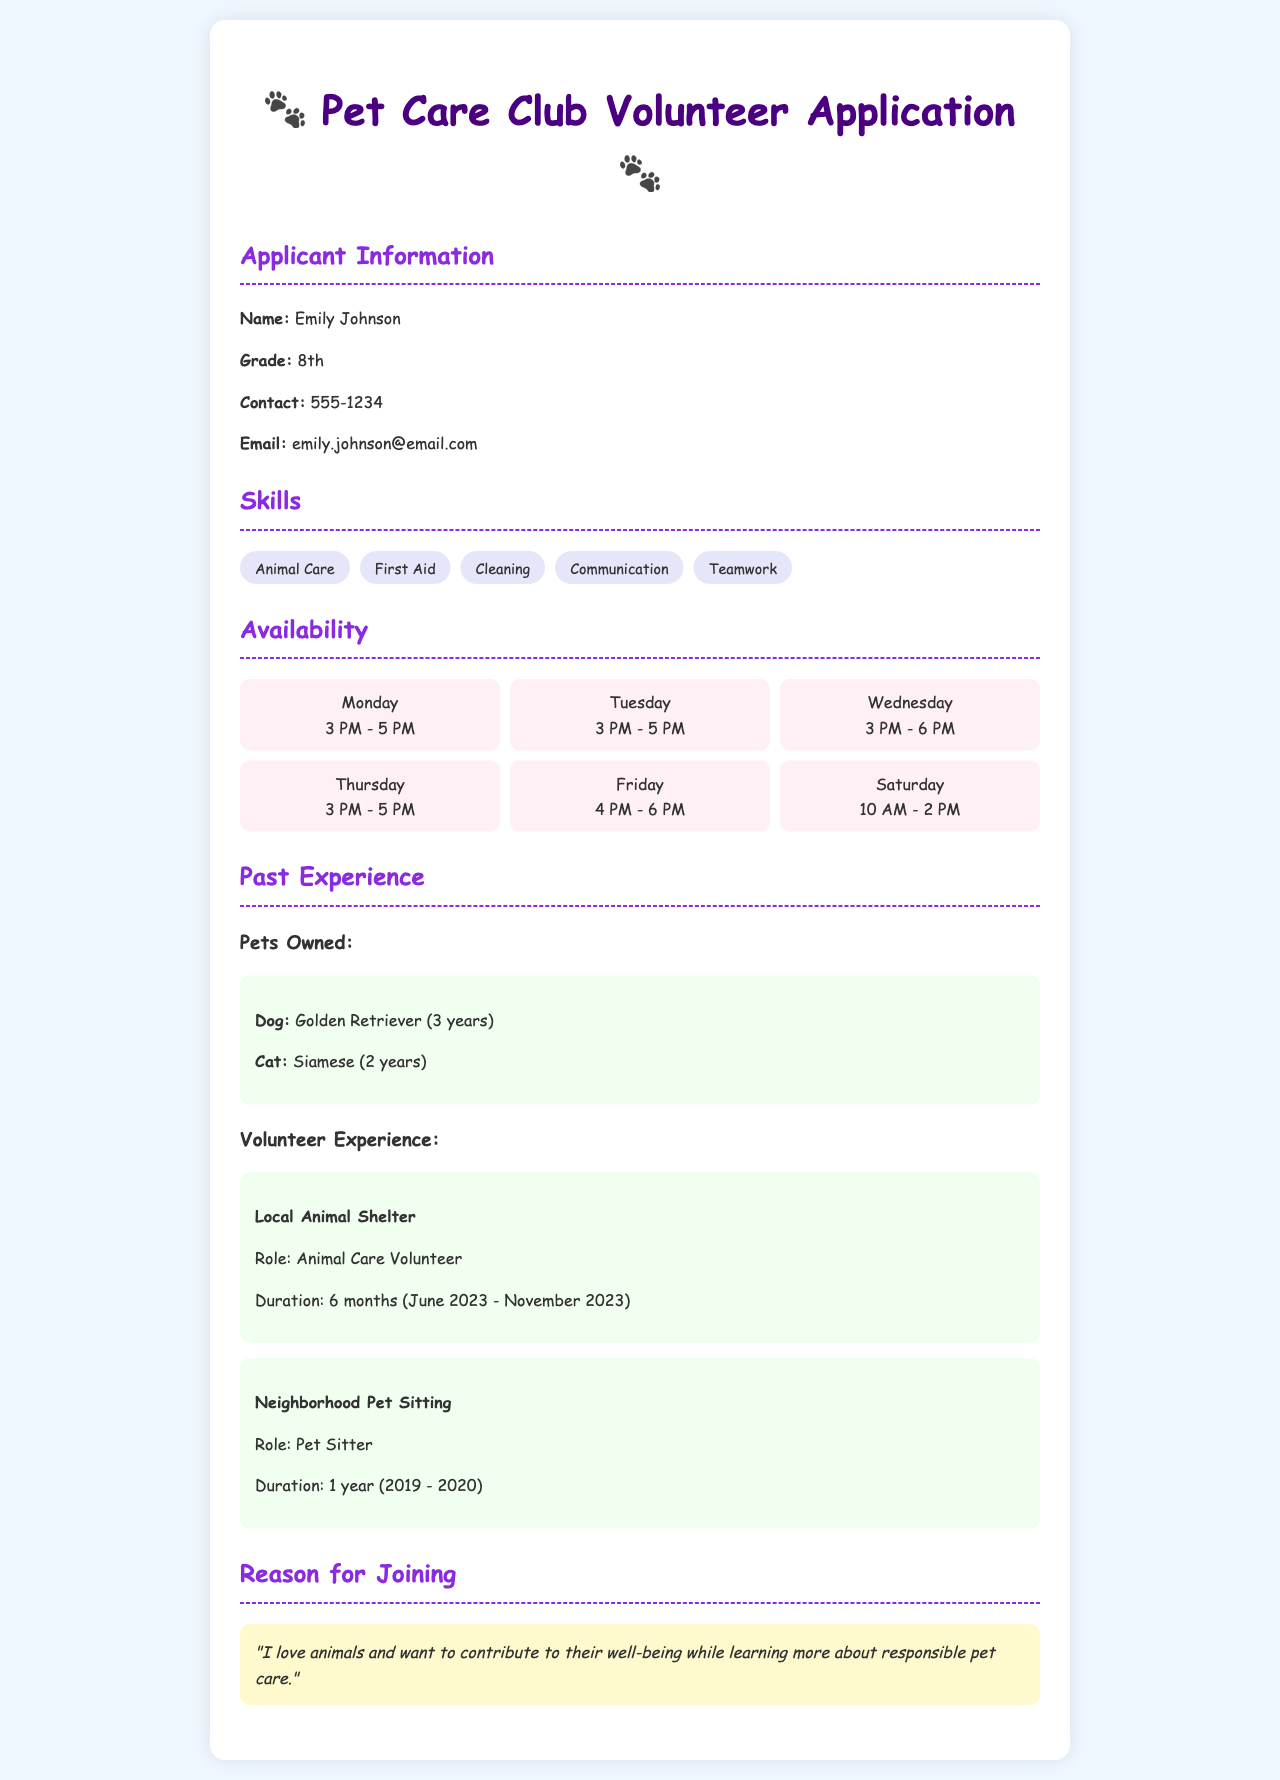What is the name of the applicant? The applicant's name is stated in the Applicant Information section of the document.
Answer: Emily Johnson What grade is Emily in? The grade of the applicant is provided in the Applicant Information section.
Answer: 8th How many pets does Emily own, and what types? The document lists the types and number of pets owned by Emily in the Past Experience section.
Answer: 1 Dog, 1 Cat What are the days Emily is available to volunteer? The availability days are outlined in the Availability section, listing specific days of the week.
Answer: Monday, Tuesday, Wednesday, Thursday, Friday, Saturday What is the duration of Emily's volunteer experience at the local animal shelter? The duration of Emily's volunteer experience is mentioned in the Past Experience section of the document.
Answer: 6 months Why does Emily want to join the Pet Care Club? The reason for joining is provided in the Reason for Joining section and articulates Emily's motivation.
Answer: "I love animals and want to contribute to their well-being while learning more about responsible pet care." Which skill does Emily list that involves communication? The skills listed in the document include specific competencies related to interacting with others.
Answer: Communication How long did Emily work as a pet sitter? The duration of Emily's work experience as a pet sitter is provided in the Past Experience section of the document.
Answer: 1 year What is one of Emily's skills related to animal care? The skills listed under the Skills section include various abilities relevant to working with animals.
Answer: Animal Care 